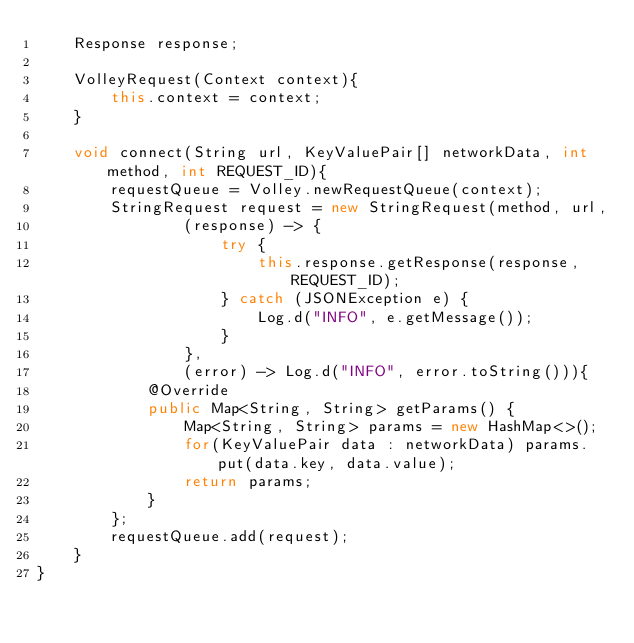Convert code to text. <code><loc_0><loc_0><loc_500><loc_500><_Java_>    Response response;

    VolleyRequest(Context context){
        this.context = context;
    }

    void connect(String url, KeyValuePair[] networkData, int method, int REQUEST_ID){
        requestQueue = Volley.newRequestQueue(context);
        StringRequest request = new StringRequest(method, url,
                (response) -> {
                    try {
                        this.response.getResponse(response, REQUEST_ID);
                    } catch (JSONException e) {
                        Log.d("INFO", e.getMessage());
                    }
                },
                (error) -> Log.d("INFO", error.toString())){
            @Override
            public Map<String, String> getParams() {
                Map<String, String> params = new HashMap<>();
                for(KeyValuePair data : networkData) params.put(data.key, data.value);
                return params;
            }
        };
        requestQueue.add(request);
    }
}
</code> 